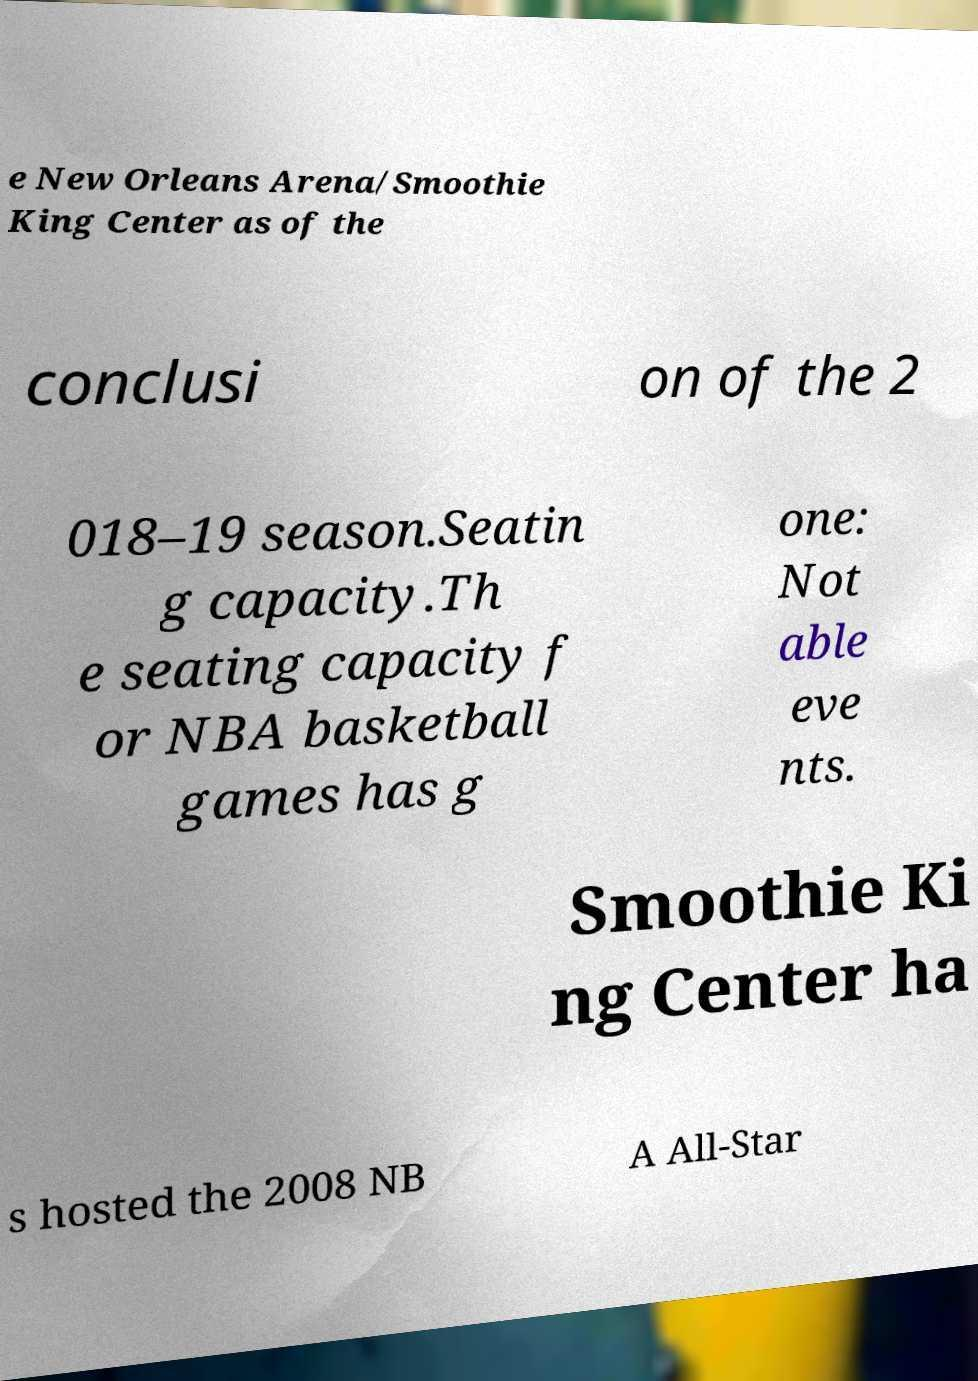Please identify and transcribe the text found in this image. e New Orleans Arena/Smoothie King Center as of the conclusi on of the 2 018–19 season.Seatin g capacity.Th e seating capacity f or NBA basketball games has g one: Not able eve nts. Smoothie Ki ng Center ha s hosted the 2008 NB A All-Star 